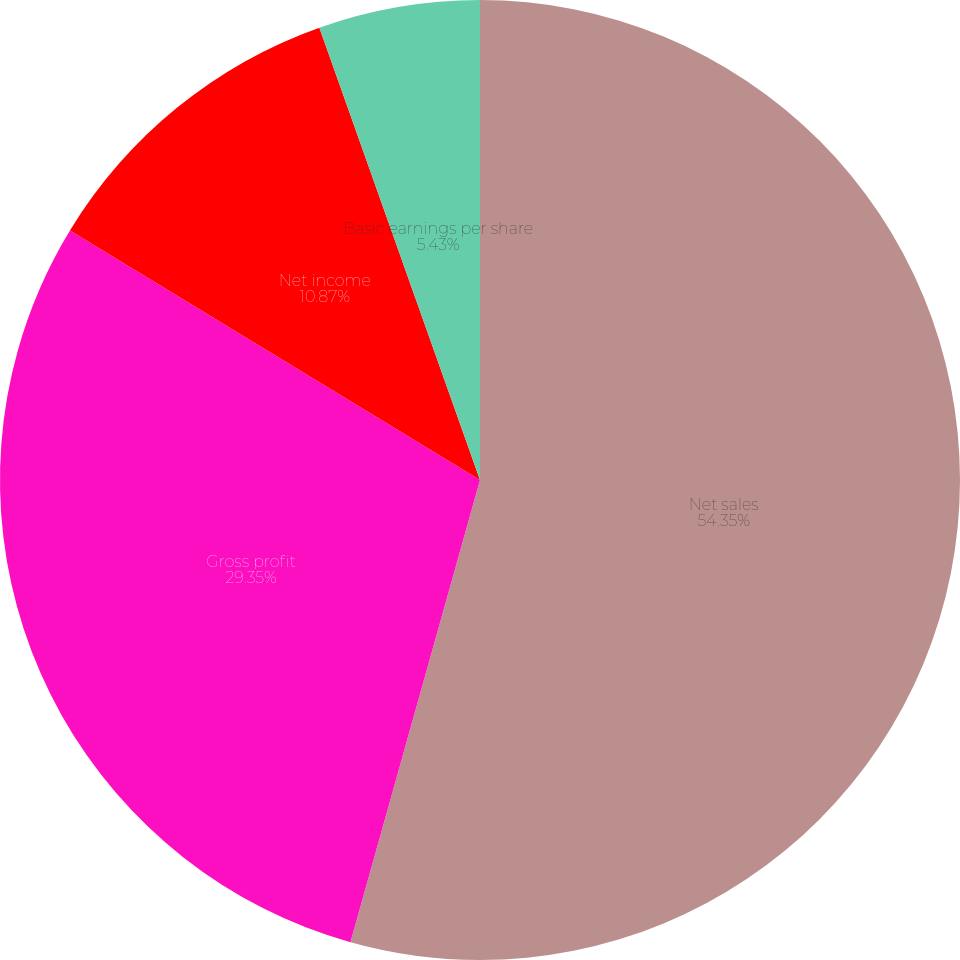<chart> <loc_0><loc_0><loc_500><loc_500><pie_chart><fcel>Net sales<fcel>Gross profit<fcel>Net income<fcel>Basic earnings per share<fcel>Diluted earnings per share<nl><fcel>54.35%<fcel>29.35%<fcel>10.87%<fcel>5.43%<fcel>0.0%<nl></chart> 